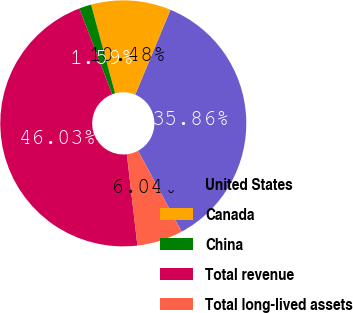Convert chart to OTSL. <chart><loc_0><loc_0><loc_500><loc_500><pie_chart><fcel>United States<fcel>Canada<fcel>China<fcel>Total revenue<fcel>Total long-lived assets<nl><fcel>35.86%<fcel>10.48%<fcel>1.59%<fcel>46.03%<fcel>6.04%<nl></chart> 